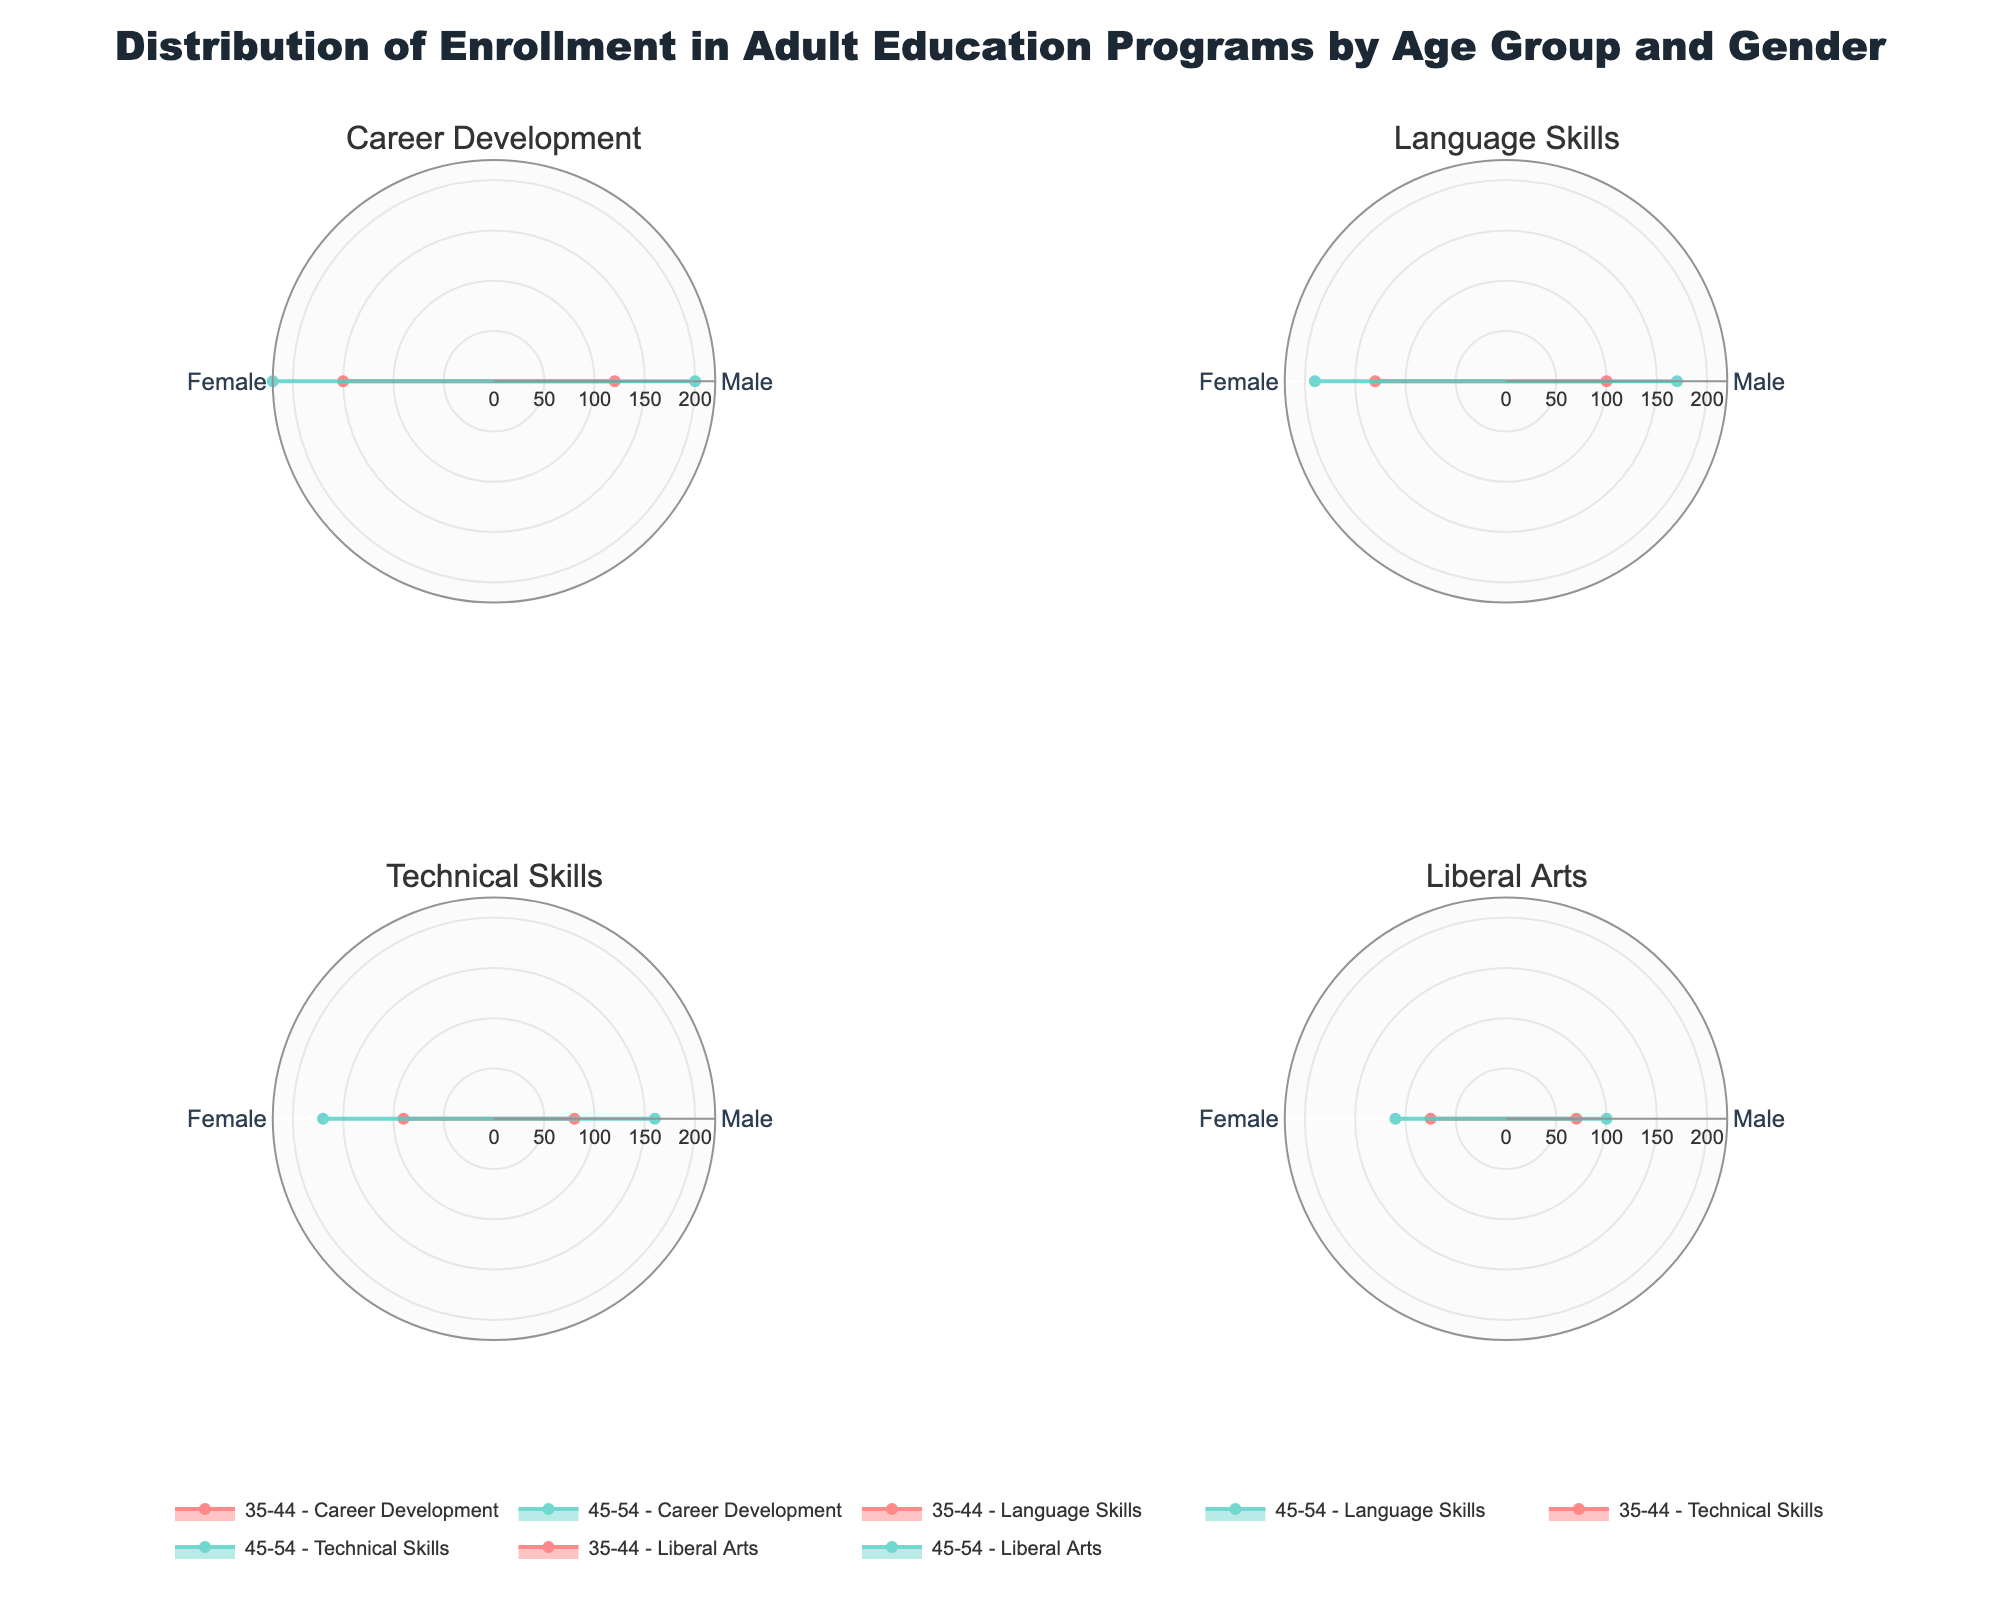what is the title of the figure? The title of the figure is located at the top center and is usually descriptive of the content. It reads "Distribution of Enrollment in Adult Education Programs by Age Group and Gender".
Answer: Distribution of Enrollment in Adult Education Programs by Age Group and Gender Which gender has more enrollments in Career Development for the 45-54 age group? Look at the subplot titled "Career Development" and compare the radial lengths of Male and Female in the 45-54 age group. The Female line is longer.
Answer: Female What is the difference in enrollments between males and females in the Language Skills program for the 35-44 age group? In the subplot titled "Language Skills", find the radial lengths for both males and females in the 35-44 age group. Males have 100 enrollments, and females have 130. Subtract 100 from 130.
Answer: 30 Which program has the highest total enrollments for the 35-44 age group? Add the enrollments for both genders in each program for the 35-44 age group: Career Development (120+150), Language Skills (100+130), Technical Skills (80+90), Liberal Arts (70+75). The highest total is for Career Development.
Answer: Career Development In the Technical Skills program, which age group has higher total enrollments? Find the radial lengths for both genders in both age groups in the Technical Skills subplot. Add the enrollments for the 35-44 age group (80+90) and for the 45-54 age group (160+170). Compare the two sums.
Answer: 45-54 How many subplots are there in the figure? The entire figure consists of multiple subplots, each representing a different program type, forming a 2x2 grid.
Answer: 4 Which gender has more enrollments in the Liberal Arts program for the 35-44 age group? Look at the subplot titled "Liberal Arts" and compare the radial lengths for males and females within the 35-44 age group. The Female line is slightly longer.
Answer: Female For the 45-54 age group in the Language Skills program, which gender has the least enrollments? Look at the subplot titled "Language Skills" and the part of the subplot for 45-54. Compare the radial lengths for males and females. The male line is shorter.
Answer: Male 